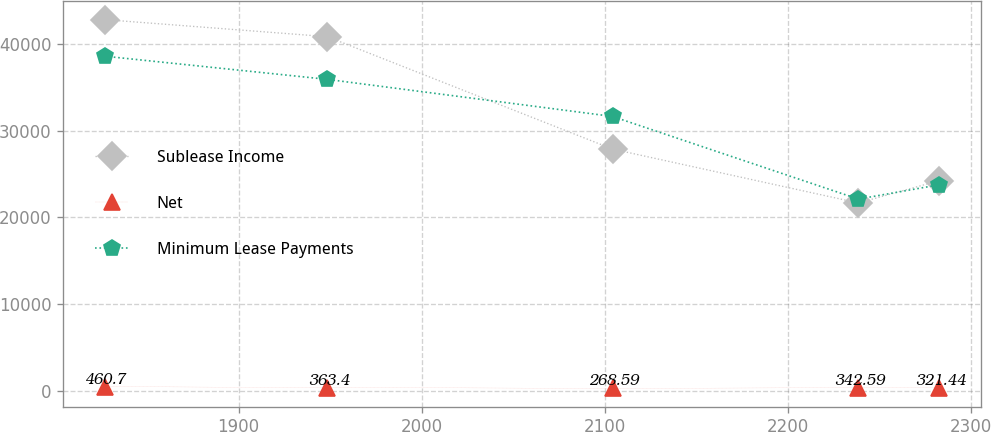Convert chart to OTSL. <chart><loc_0><loc_0><loc_500><loc_500><line_chart><ecel><fcel>Sublease Income<fcel>Net<fcel>Minimum Lease Payments<nl><fcel>1826.97<fcel>42823.9<fcel>460.7<fcel>38601.9<nl><fcel>1948.46<fcel>40858.4<fcel>363.4<fcel>35931.2<nl><fcel>2104.28<fcel>27885.7<fcel>268.59<fcel>31650.4<nl><fcel>2238.58<fcel>21667.7<fcel>342.59<fcel>22111<nl><fcel>2282.62<fcel>24233.3<fcel>321.44<fcel>23760.1<nl></chart> 